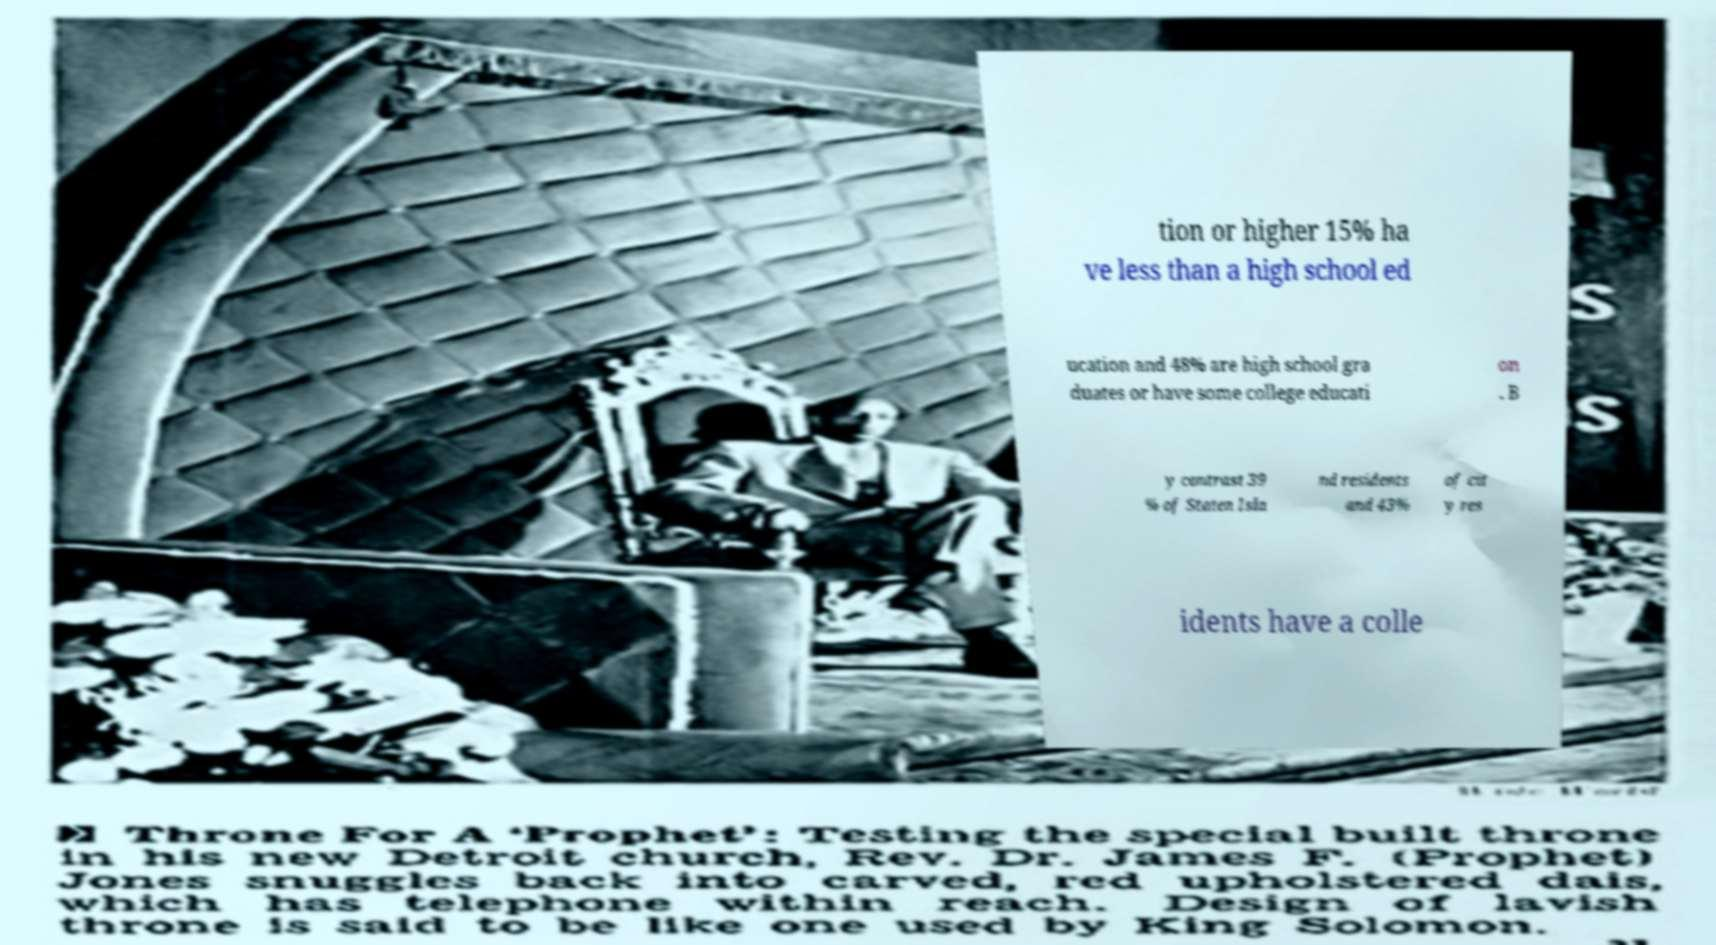Could you assist in decoding the text presented in this image and type it out clearly? tion or higher 15% ha ve less than a high school ed ucation and 48% are high school gra duates or have some college educati on . B y contrast 39 % of Staten Isla nd residents and 43% of cit y res idents have a colle 